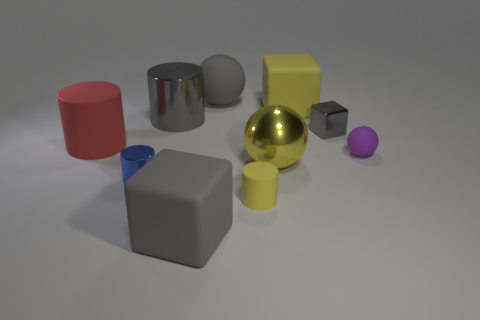There is a red rubber object; is it the same size as the gray shiny object that is to the left of the gray matte block?
Your response must be concise. Yes. How many shiny things are either small red objects or large gray spheres?
Your answer should be very brief. 0. What number of yellow metallic objects have the same shape as the big yellow rubber thing?
Your response must be concise. 0. What material is the large cylinder that is the same color as the small block?
Your answer should be compact. Metal. There is a rubber ball that is on the right side of the large yellow rubber thing; does it have the same size as the gray cube on the right side of the tiny yellow thing?
Offer a very short reply. Yes. There is a object behind the large yellow block; what shape is it?
Offer a very short reply. Sphere. What material is the gray thing that is the same shape as the small blue object?
Keep it short and to the point. Metal. Do the gray rubber object in front of the blue thing and the red cylinder have the same size?
Provide a succinct answer. Yes. There is a tiny ball; how many large gray matte objects are behind it?
Ensure brevity in your answer.  1. Is the number of tiny blue cylinders behind the big rubber cylinder less than the number of gray blocks that are left of the large yellow ball?
Your answer should be compact. Yes. 